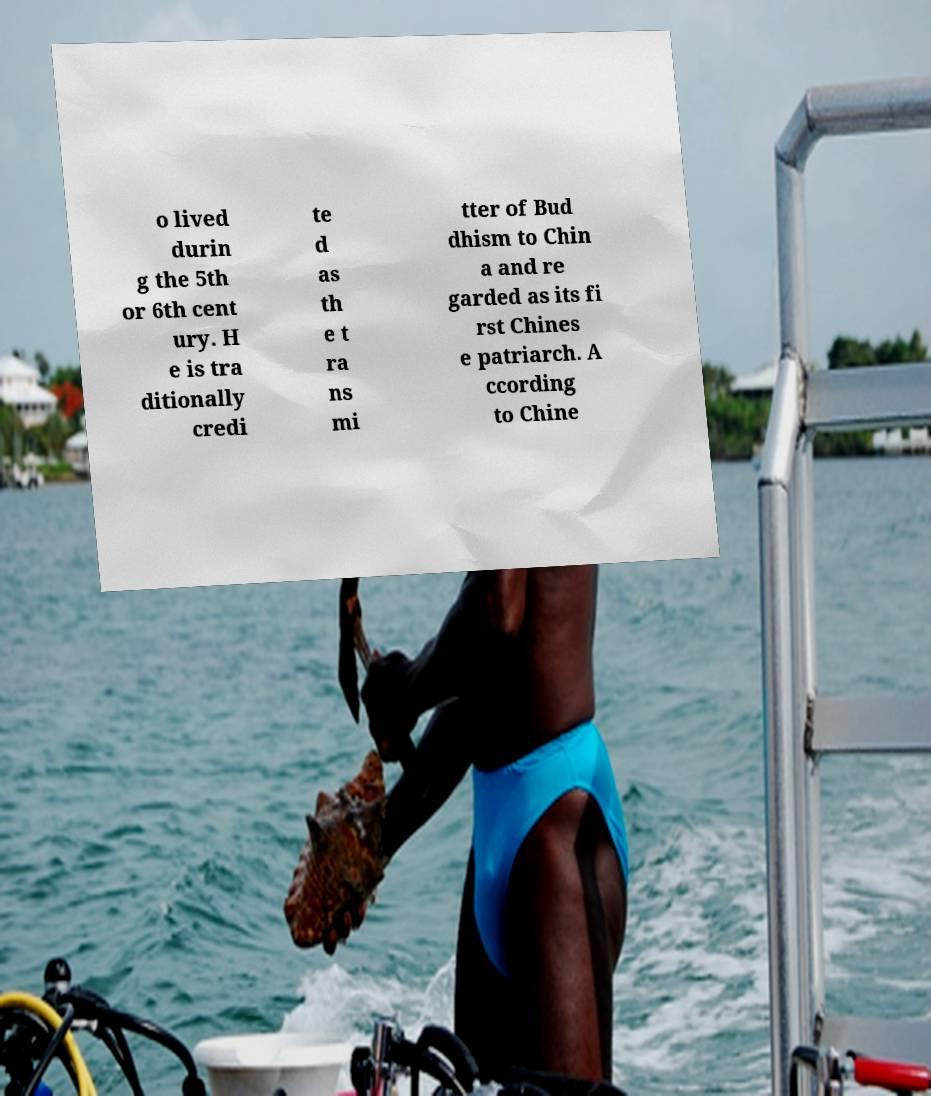Can you read and provide the text displayed in the image?This photo seems to have some interesting text. Can you extract and type it out for me? o lived durin g the 5th or 6th cent ury. H e is tra ditionally credi te d as th e t ra ns mi tter of Bud dhism to Chin a and re garded as its fi rst Chines e patriarch. A ccording to Chine 